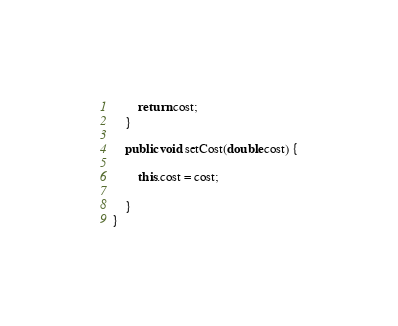<code> <loc_0><loc_0><loc_500><loc_500><_Java_>        return cost;
    }

    public void setCost(double cost) {

        this.cost = cost;

    }
}
</code> 